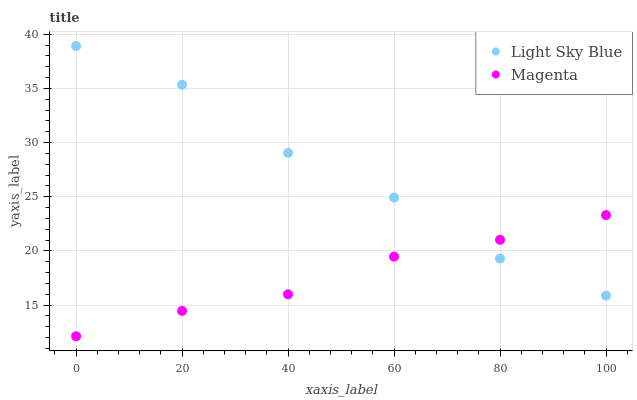Does Magenta have the minimum area under the curve?
Answer yes or no. Yes. Does Light Sky Blue have the maximum area under the curve?
Answer yes or no. Yes. Does Light Sky Blue have the minimum area under the curve?
Answer yes or no. No. Is Magenta the smoothest?
Answer yes or no. Yes. Is Light Sky Blue the roughest?
Answer yes or no. Yes. Is Light Sky Blue the smoothest?
Answer yes or no. No. Does Magenta have the lowest value?
Answer yes or no. Yes. Does Light Sky Blue have the lowest value?
Answer yes or no. No. Does Light Sky Blue have the highest value?
Answer yes or no. Yes. Does Light Sky Blue intersect Magenta?
Answer yes or no. Yes. Is Light Sky Blue less than Magenta?
Answer yes or no. No. Is Light Sky Blue greater than Magenta?
Answer yes or no. No. 